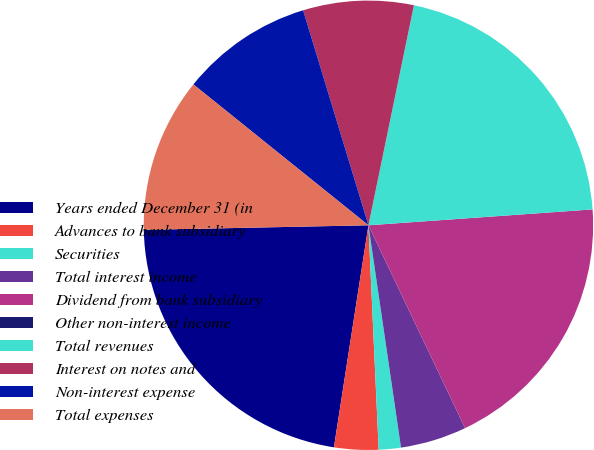<chart> <loc_0><loc_0><loc_500><loc_500><pie_chart><fcel>Years ended December 31 (in<fcel>Advances to bank subsidiary<fcel>Securities<fcel>Total interest income<fcel>Dividend from bank subsidiary<fcel>Other non-interest income<fcel>Total revenues<fcel>Interest on notes and<fcel>Non-interest expense<fcel>Total expenses<nl><fcel>22.22%<fcel>3.18%<fcel>1.59%<fcel>4.76%<fcel>19.05%<fcel>0.0%<fcel>20.63%<fcel>7.94%<fcel>9.52%<fcel>11.11%<nl></chart> 